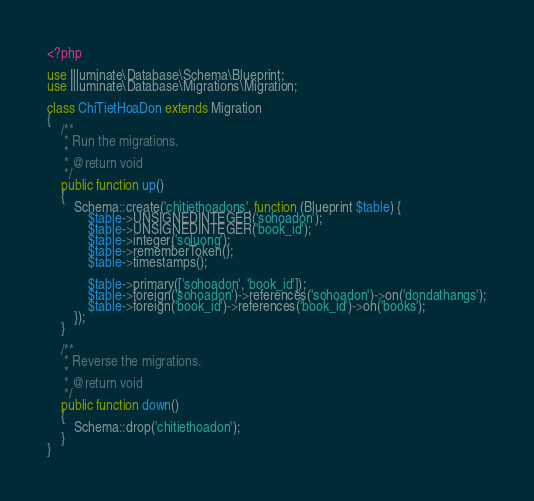<code> <loc_0><loc_0><loc_500><loc_500><_PHP_><?php

use Illuminate\Database\Schema\Blueprint;
use Illuminate\Database\Migrations\Migration;

class ChiTietHoaDon extends Migration
{
    /**
     * Run the migrations.
     *
     * @return void
     */
    public function up()
    {
        Schema::create('chitiethoadons', function (Blueprint $table) {
            $table->UNSIGNEDINTEGER('sohoadon');
            $table->UNSIGNEDINTEGER('book_id');
            $table->integer('soluong');
            $table->rememberToken();
            $table->timestamps();

            $table->primary(['sohoadon', 'book_id']);
            $table->foreign('sohoadon')->references('sohoadon')->on('dondathangs');
            $table->foreign('book_id')->references('book_id')->on('books');
        });
    }

    /**
     * Reverse the migrations.
     *
     * @return void
     */
    public function down()
    {
        Schema::drop('chitiethoadon');
    }
}
</code> 